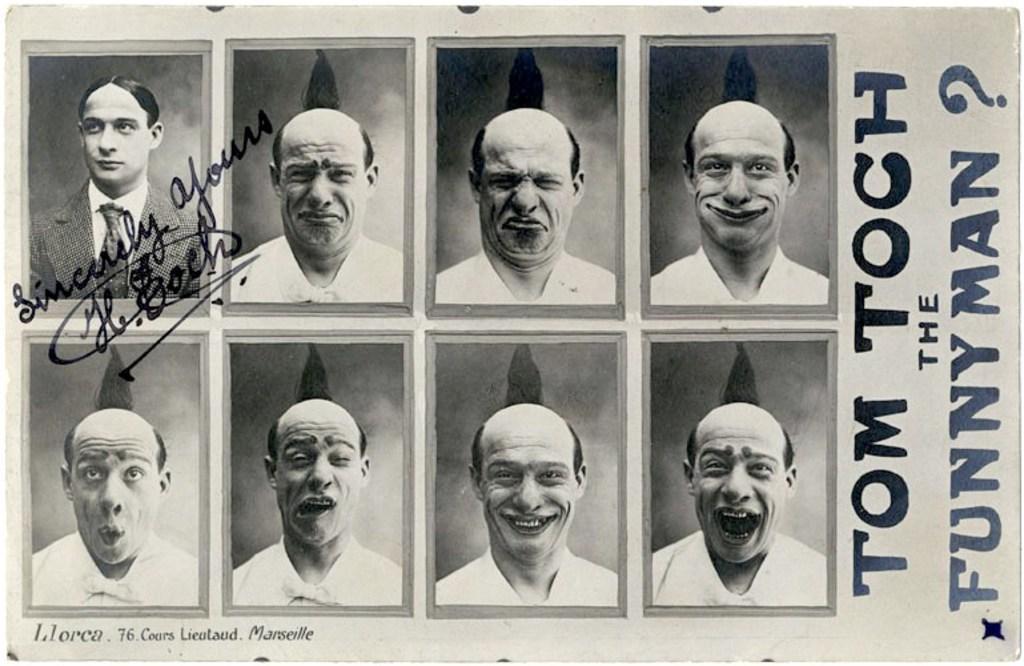How would you summarize this image in a sentence or two? In this image we can see a paper. On the paper, we can see the images of the persons and the text. 